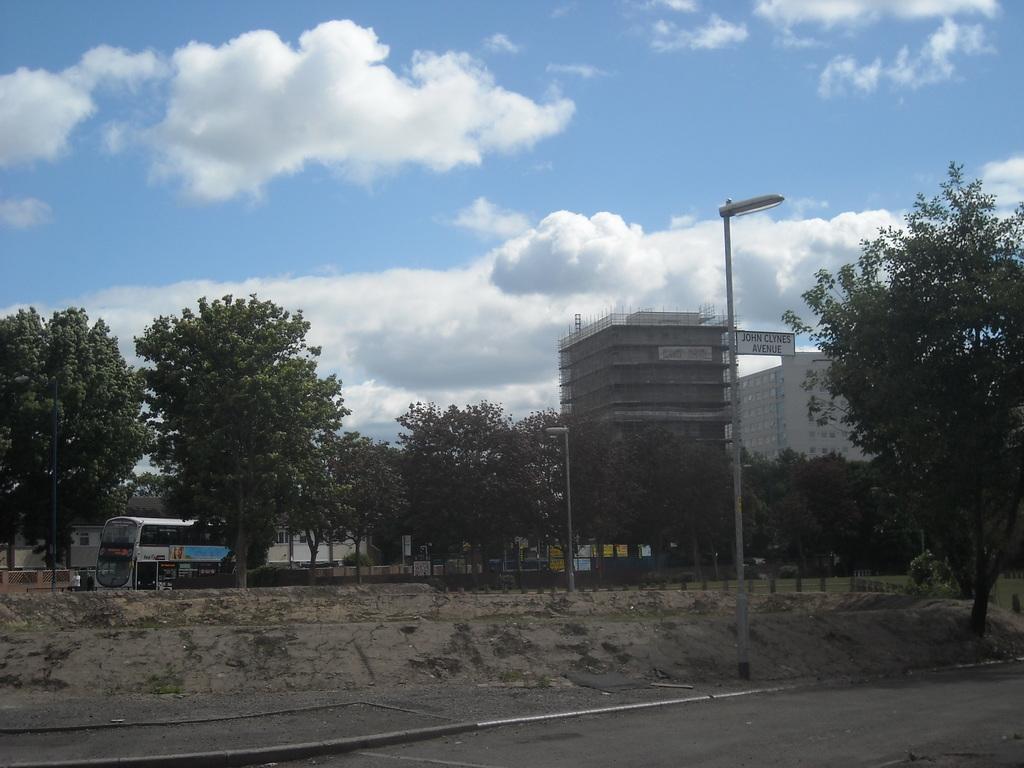Can you describe this image briefly? In this picture we can see few poles, trees and vehicles, in the background we can find few buildings, hoardings and clouds. 